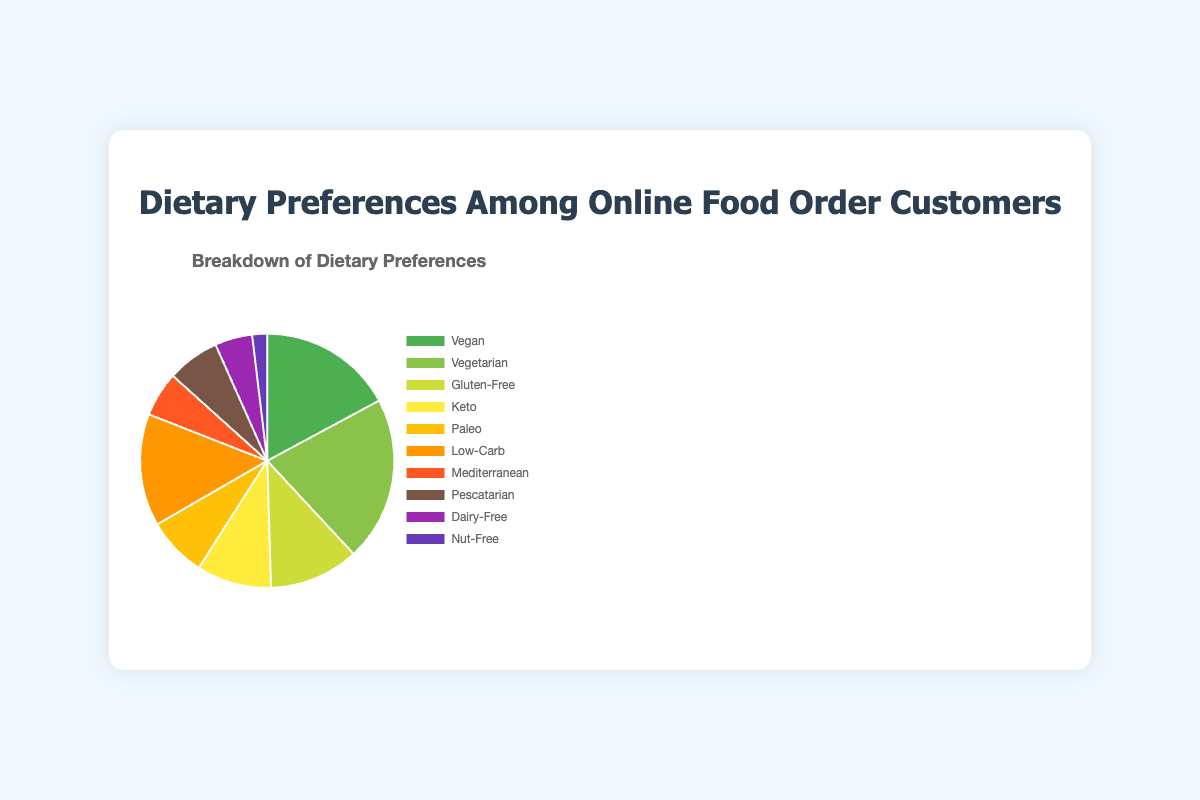What is the most popular dietary preference among online food order customers? The most popular dietary preference can be identified by looking for the largest segment in the pie chart. The segment with the largest value is Vegetarian with 22 customers.
Answer: Vegetarian Which dietary preference has the smallest number of customers? The smallest segment in the pie chart represents the dietary preference with the least number of customers. Nut-Free, with only 2 customers, has the smallest segment.
Answer: Nut-Free What is the total number of customers following Vegan and Vegetarian diets combined? Add the number of Vegan (18) and Vegetarian (22) customers: 18 + 22 = 40
Answer: 40 How many more customers prefer a Low-Carb diet compared to a Mediterranean diet? Subtract the number of Mediterranean (6) customers from the number of Low-Carb (15) customers: 15 - 6 = 9
Answer: 9 Which dietary preference appears directly to the right of Mediterranean in the pie chart legend? The pie chart legend lists the preferences in the same order from the top to the bottom, corresponding with the segments. The preference directly to the right of Mediterranean (6) is Pescatarian (7).
Answer: Pescatarian If you combine the number of customers for Gluten-Free, Keto, and Paleo diets, what percentage of the total does this represent? First, add the number of Gluten-Free (12), Keto (10), and Paleo (8) customers: 12 + 10 + 8 = 30. Then, calculate the percentage of the total number of customers: (30 / (18 + 22 + 12 + 10 + 8 + 15 + 6 + 7 + 5 + 2)) * 100 ≈ 30/105 * 100 ≈ 28.6%
Answer: ~28.6% Which has more customers, Vegan and Vegetarian combined or Gluten-Free, Keto, and Paleo combined? Calculate the sum for each combination. Vegan and Vegetarian: 18 + 22 = 40. Gluten-Free, Keto, and Paleo: 12 + 10 + 8 = 30. Thus, Vegan and Vegetarian have more customers.
Answer: Vegan and Vegetarian How many customers prefer diets that are specifically avoiding certain food items (Dairy-Free and Nut-Free)? Add the number of Dairy-Free (5) and Nut-Free (2) customers: 5 + 2 = 7
Answer: 7 What proportion of the total dietary preferences does Pescatarian account for? The number of customers for Pescatarian is 7. To find the proportion, divide this by the total number of customers and multiply by 100: (7 / 105) * 100 ≈ 6.67%
Answer: ~6.67% Are there more customers who prefer Low-Carb diets than those who prefer Keto and Dairy-Free diets combined? First, add the number of Keto (10) and Dairy-Free (5) customers: 10 + 5 = 15. The number of Low-Carb customers is 15. Since 15 is equal to 15, there are as many Low-Carb as Keto and Dairy-Free combined.
Answer: Equal 